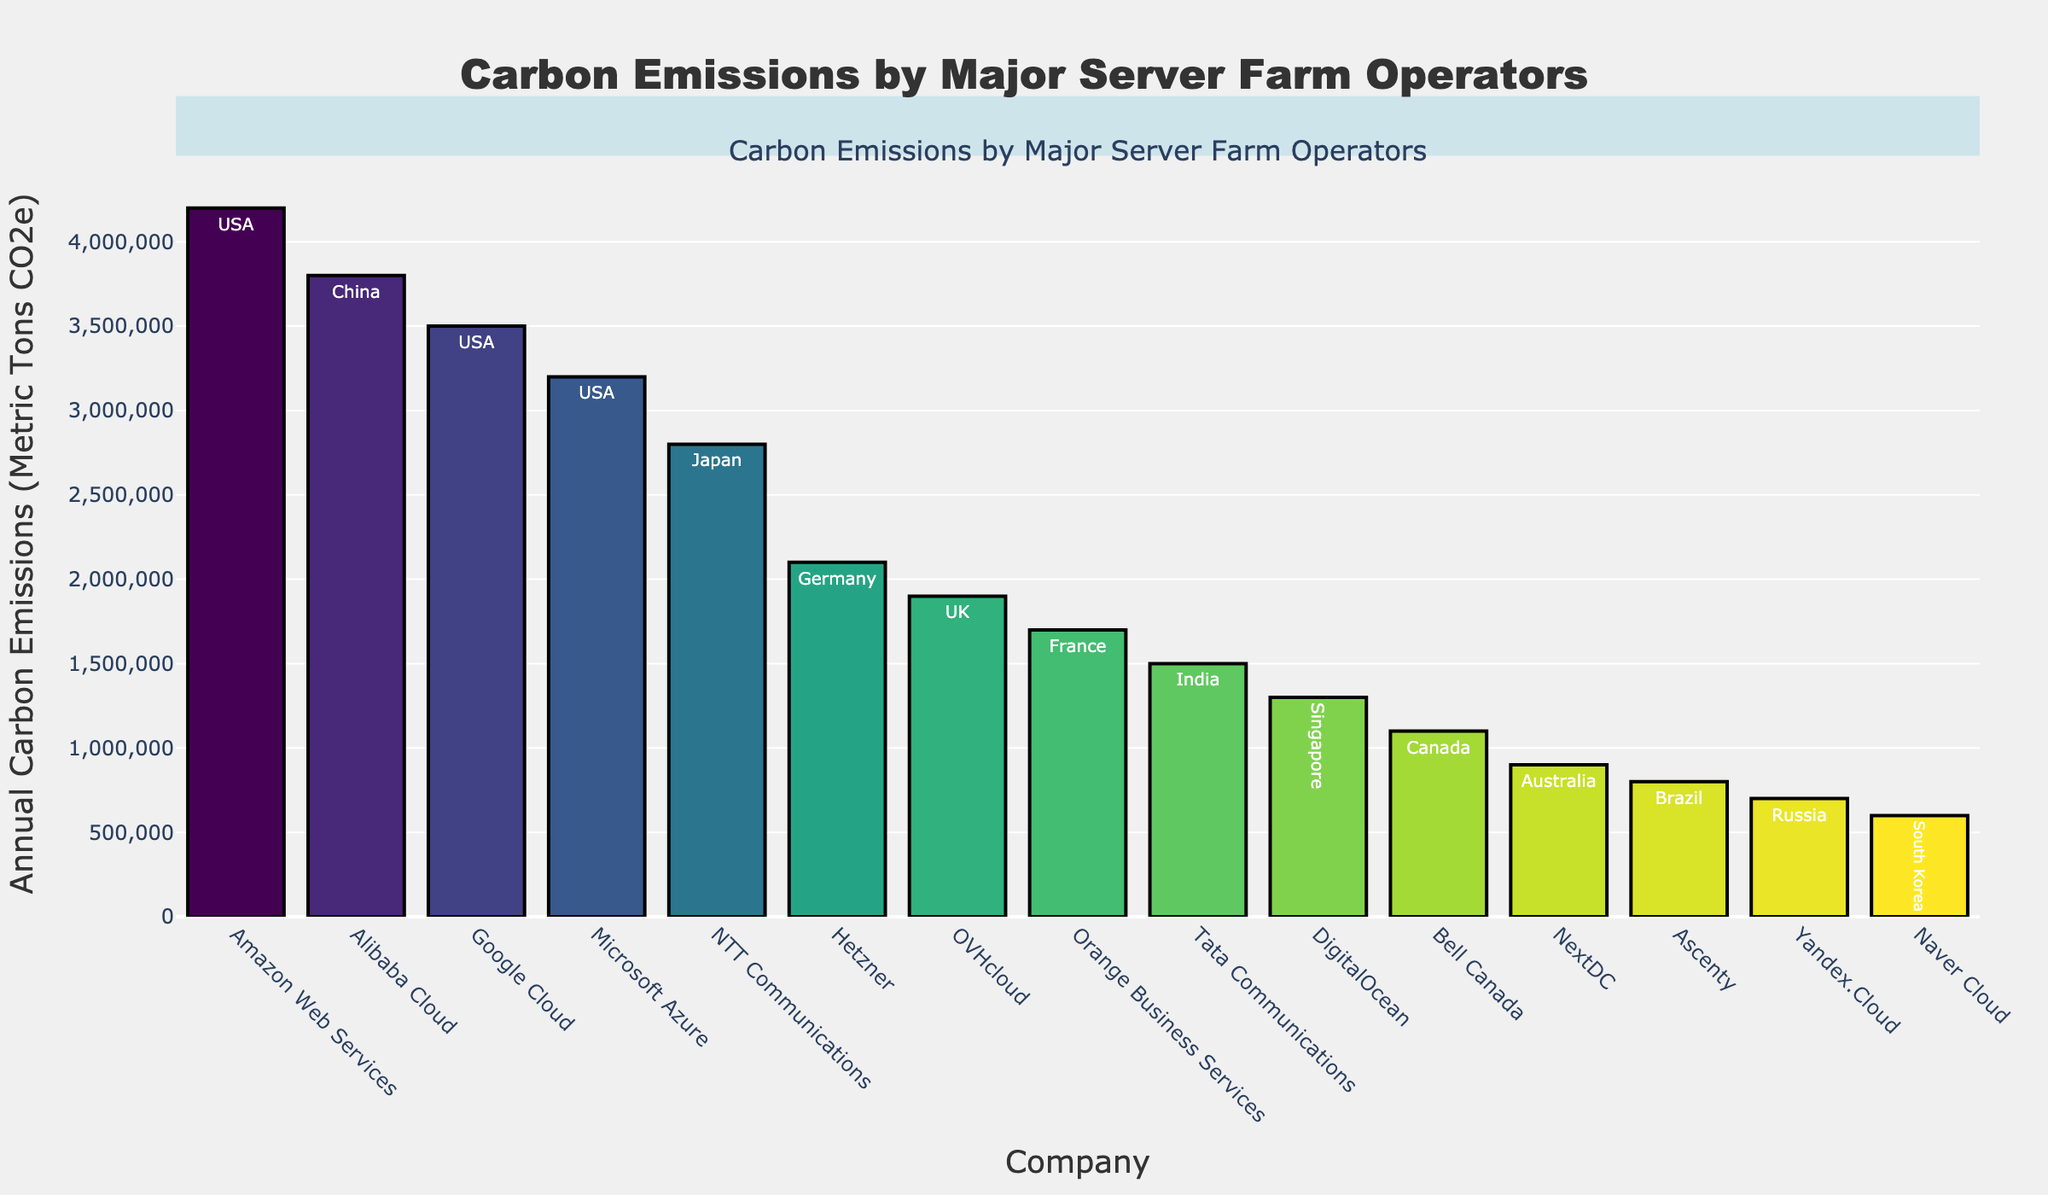Which company has the highest annual carbon emissions? The tallest bar in the chart represents the company with the highest annual carbon emissions. The tallest bar corresponds to Amazon Web Services.
Answer: Amazon Web Services Which country has the most companies listed in the chart? By analyzing the text inside the bars, we can count the number of companies from each country. The USA has Amazon Web Services, Google Cloud, and Microsoft Azure, making it the country with the most companies listed.
Answer: USA What is the combined annual carbon emission of Google Cloud and Microsoft Azure? Google Cloud has 3,500,000 metric tons CO2e and Microsoft Azure has 3,200,000 metric tons CO2e. Adding these together gives 6,700,000 metric tons CO2e.
Answer: 6,700,000 metric tons CO2e Are Amazon Web Services' emissions greater than the combined emissions of NTT Communications and Hetzner? Amazon Web Services has 4,200,000 metric tons CO2e. NTT Communications has 2,800,000 metric tons CO2e, and Hetzner has 2,100,000 metric tons CO2e. Adding NTT Communications and Hetzner emissions gives 4,900,000 metric tons CO2e, which is greater than Amazon Web Services' emissions.
Answer: No Which company has the lowest carbon emissions, and what is the value? The shortest bar in the chart represents the company with the lowest carbon emissions. The shortest bar corresponds to Naver Cloud with 600,000 metric tons CO2e.
Answer: Naver Cloud, 600,000 metric tons CO2e What is the difference in annual carbon emissions between Alibaba Cloud and Microsoft Azure? Alibaba Cloud has 3,800,000 metric tons CO2e and Microsoft Azure has 3,200,000 metric tons CO2e. The difference is 3,800,000 - 3,200,000 = 600,000 metric tons CO2e.
Answer: 600,000 metric tons CO2e Which company emits less carbon annually, Orange Business Services or Tata Communications, and by how much? Orange Business Services emits 1,700,000 metric tons CO2e and Tata Communications emits 1,500,000 metric tons CO2e. To find the difference, subtract 1,500,000 from 1,700,000, which gives 200,000 metric tons CO2e.
Answer: Tata Communications, 200,000 metric tons CO2e How many companies have annual carbon emissions greater than 3,000,000 metric tons CO2e? By referring to the bars in the chart, we can count companies with emissions greater than 3,000,000 metric tons CO2e—Amazon Web Services, Alibaba Cloud, Google Cloud, and Microsoft Azure. There are four companies.
Answer: 4 Which company's bar is approximately in the middle of the chart in terms of height? The middle bar in terms of height corresponds to the median value. With 15 companies listed, the 8th company by height is OVHcloud with 1,900,000 metric tons CO2e.
Answer: OVHcloud 